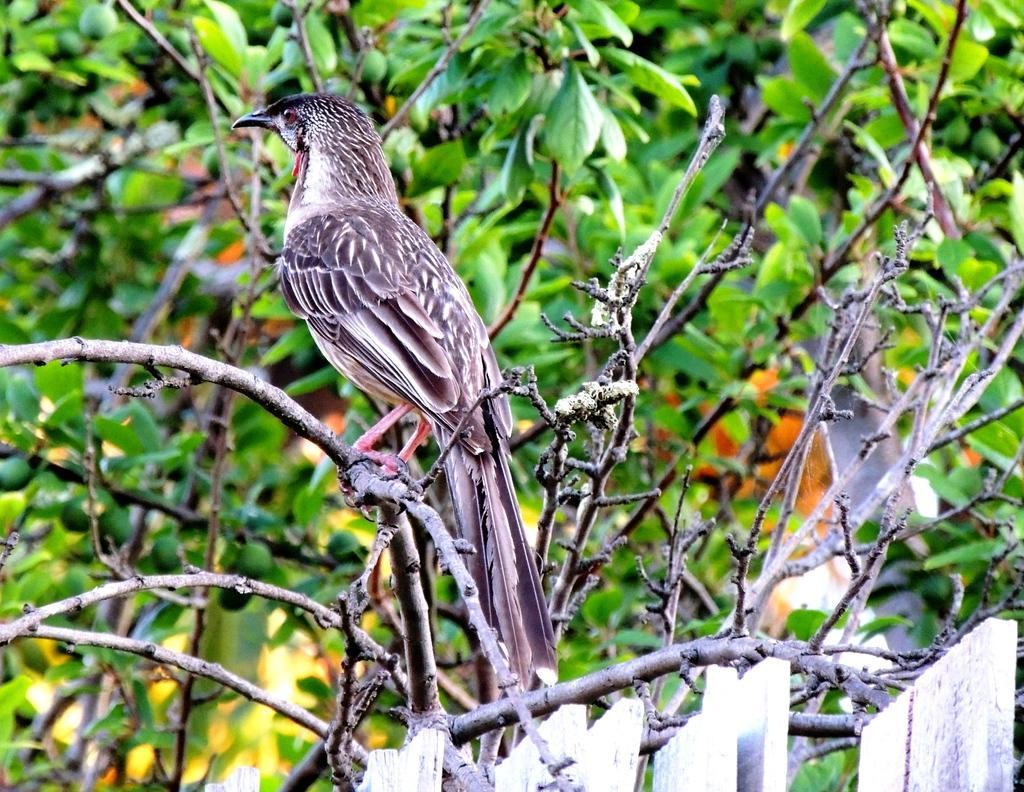Please provide a concise description of this image. In this picture we can see a bird on a branch and in the background we can see trees. 